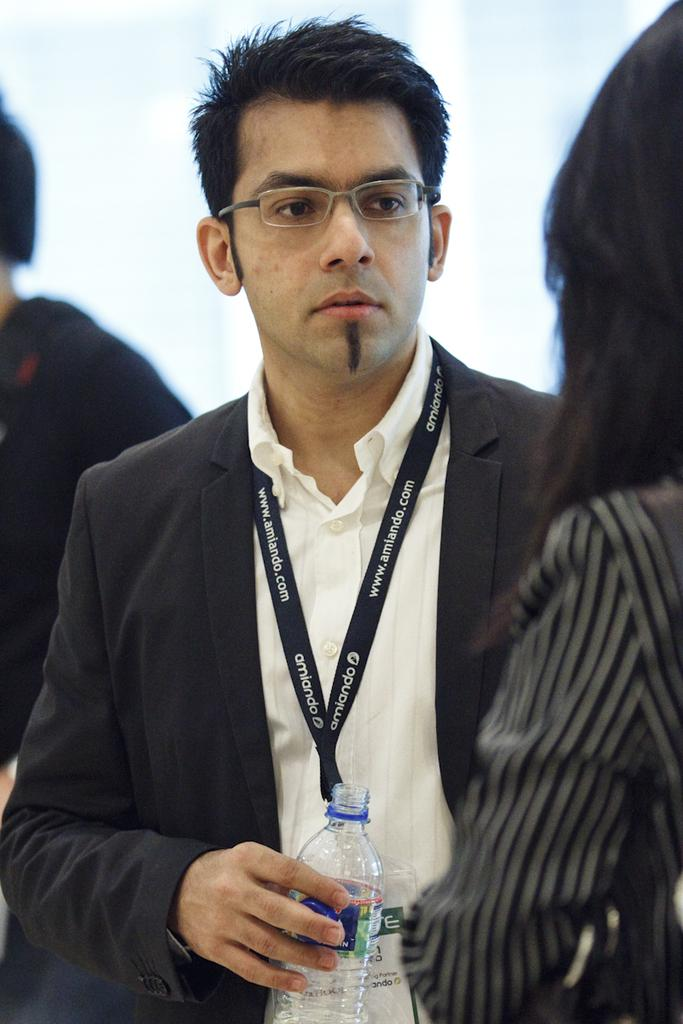Who is the main subject in the center of the image? There is a man in the center of the image holding a water bottle. Can you describe the other people in the image? There is a woman standing on the right side of the image and a man standing on the left side of the image. What year is depicted in the image? The image does not depict a specific year; it is a photograph of people in a particular arrangement. What type of jam is being used as a prop in the image? There is no jam present in the image. 